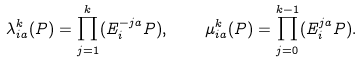<formula> <loc_0><loc_0><loc_500><loc_500>\lambda _ { i a } ^ { k } ( P ) = \prod _ { j = 1 } ^ { k } ( E _ { i } ^ { - j a } P ) , \quad \mu _ { i a } ^ { k } ( P ) = \prod _ { j = 0 } ^ { k - 1 } ( E _ { i } ^ { j a } P ) .</formula> 